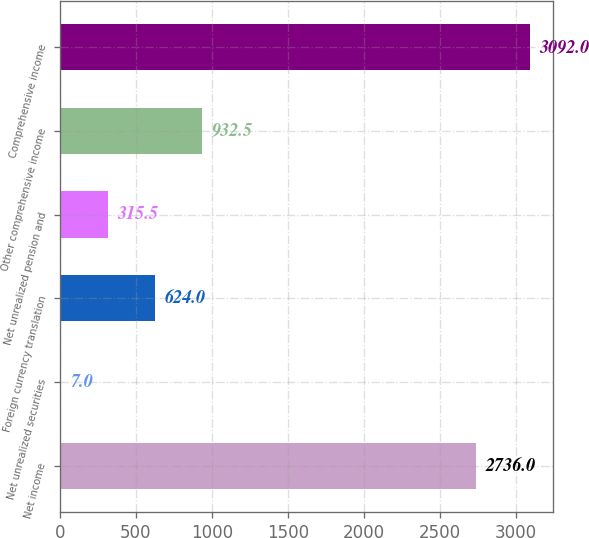<chart> <loc_0><loc_0><loc_500><loc_500><bar_chart><fcel>Net income<fcel>Net unrealized securities<fcel>Foreign currency translation<fcel>Net unrealized pension and<fcel>Other comprehensive income<fcel>Comprehensive income<nl><fcel>2736<fcel>7<fcel>624<fcel>315.5<fcel>932.5<fcel>3092<nl></chart> 